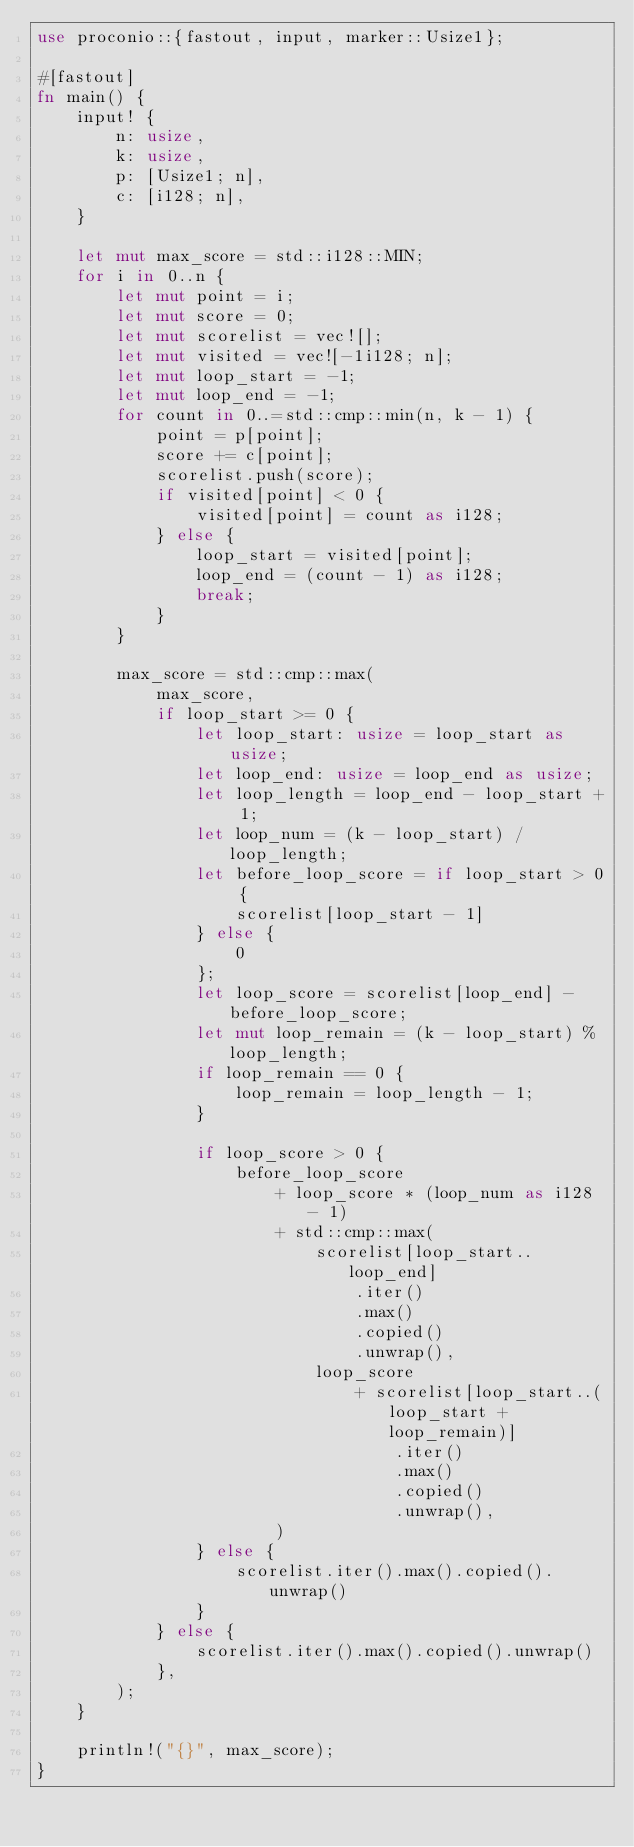Convert code to text. <code><loc_0><loc_0><loc_500><loc_500><_Rust_>use proconio::{fastout, input, marker::Usize1};

#[fastout]
fn main() {
    input! {
        n: usize,
        k: usize,
        p: [Usize1; n],
        c: [i128; n],
    }

    let mut max_score = std::i128::MIN;
    for i in 0..n {
        let mut point = i;
        let mut score = 0;
        let mut scorelist = vec![];
        let mut visited = vec![-1i128; n];
        let mut loop_start = -1;
        let mut loop_end = -1;
        for count in 0..=std::cmp::min(n, k - 1) {
            point = p[point];
            score += c[point];
            scorelist.push(score);
            if visited[point] < 0 {
                visited[point] = count as i128;
            } else {
                loop_start = visited[point];
                loop_end = (count - 1) as i128;
                break;
            }
        }

        max_score = std::cmp::max(
            max_score,
            if loop_start >= 0 {
                let loop_start: usize = loop_start as usize;
                let loop_end: usize = loop_end as usize;
                let loop_length = loop_end - loop_start + 1;
                let loop_num = (k - loop_start) / loop_length;
                let before_loop_score = if loop_start > 0 {
                    scorelist[loop_start - 1]
                } else {
                    0
                };
                let loop_score = scorelist[loop_end] - before_loop_score;
                let mut loop_remain = (k - loop_start) % loop_length;
                if loop_remain == 0 {
                    loop_remain = loop_length - 1;
                }

                if loop_score > 0 {
                    before_loop_score
                        + loop_score * (loop_num as i128 - 1)
                        + std::cmp::max(
                            scorelist[loop_start..loop_end]
                                .iter()
                                .max()
                                .copied()
                                .unwrap(),
                            loop_score
                                + scorelist[loop_start..(loop_start + loop_remain)]
                                    .iter()
                                    .max()
                                    .copied()
                                    .unwrap(),
                        )
                } else {
                    scorelist.iter().max().copied().unwrap()
                }
            } else {
                scorelist.iter().max().copied().unwrap()
            },
        );
    }

    println!("{}", max_score);
}
</code> 